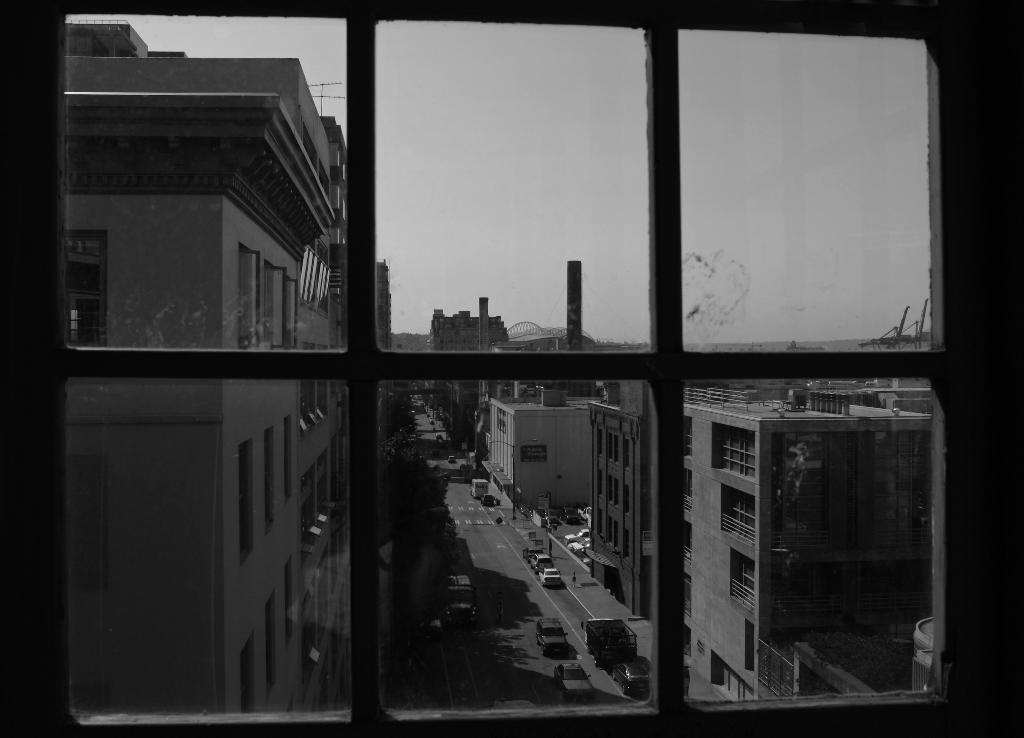What type of structure is present in the image? There is a glass window in the image. What can be seen through the glass window? Buildings, vehicles, poles, and the sky are visible through the glass window. What type of engine can be seen playing with a group of children in the image? There is no engine or group of children present in the image; it features a glass window with various objects visible through it. 